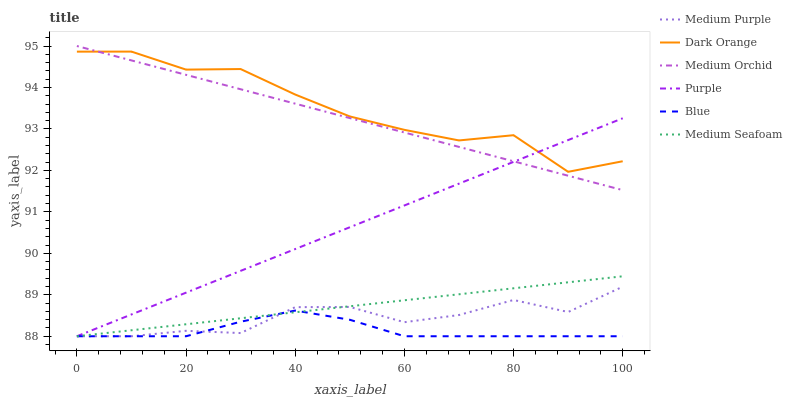Does Blue have the minimum area under the curve?
Answer yes or no. Yes. Does Dark Orange have the maximum area under the curve?
Answer yes or no. Yes. Does Purple have the minimum area under the curve?
Answer yes or no. No. Does Purple have the maximum area under the curve?
Answer yes or no. No. Is Purple the smoothest?
Answer yes or no. Yes. Is Dark Orange the roughest?
Answer yes or no. Yes. Is Dark Orange the smoothest?
Answer yes or no. No. Is Purple the roughest?
Answer yes or no. No. Does Blue have the lowest value?
Answer yes or no. Yes. Does Dark Orange have the lowest value?
Answer yes or no. No. Does Medium Orchid have the highest value?
Answer yes or no. Yes. Does Dark Orange have the highest value?
Answer yes or no. No. Is Blue less than Dark Orange?
Answer yes or no. Yes. Is Dark Orange greater than Blue?
Answer yes or no. Yes. Does Medium Purple intersect Medium Seafoam?
Answer yes or no. Yes. Is Medium Purple less than Medium Seafoam?
Answer yes or no. No. Is Medium Purple greater than Medium Seafoam?
Answer yes or no. No. Does Blue intersect Dark Orange?
Answer yes or no. No. 